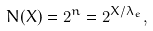Convert formula to latex. <formula><loc_0><loc_0><loc_500><loc_500>N ( X ) = 2 ^ { n } = 2 ^ { X / \lambda _ { e } } ,</formula> 